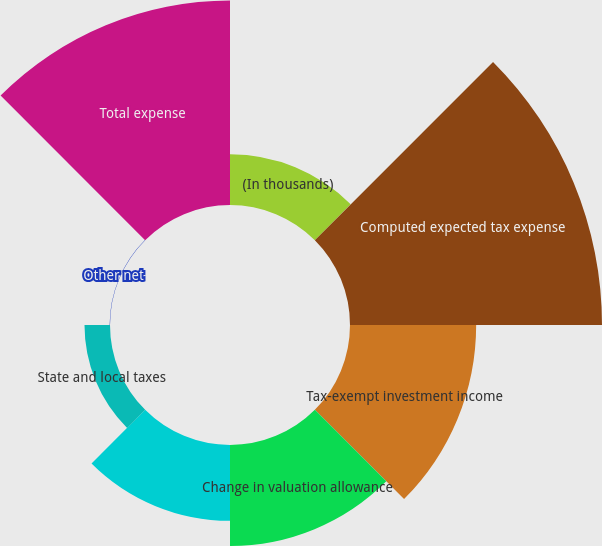Convert chart. <chart><loc_0><loc_0><loc_500><loc_500><pie_chart><fcel>(In thousands)<fcel>Computed expected tax expense<fcel>Tax-exempt investment income<fcel>Change in valuation allowance<fcel>Impact of foreign tax rates<fcel>State and local taxes<fcel>Other net<fcel>Total expense<nl><fcel>6.06%<fcel>30.14%<fcel>15.09%<fcel>12.08%<fcel>9.07%<fcel>3.05%<fcel>0.04%<fcel>24.45%<nl></chart> 